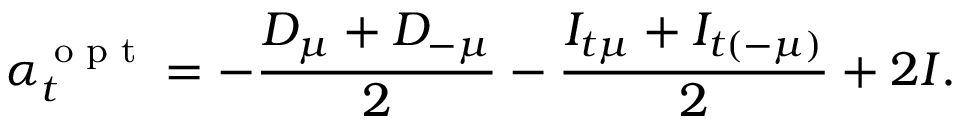Convert formula to latex. <formula><loc_0><loc_0><loc_500><loc_500>\alpha _ { t } ^ { o p t } = - \frac { D _ { \mu } + D _ { - \mu } } { 2 } - \frac { I _ { t \mu } + I _ { t ( - \mu ) } } { 2 } + 2 I .</formula> 